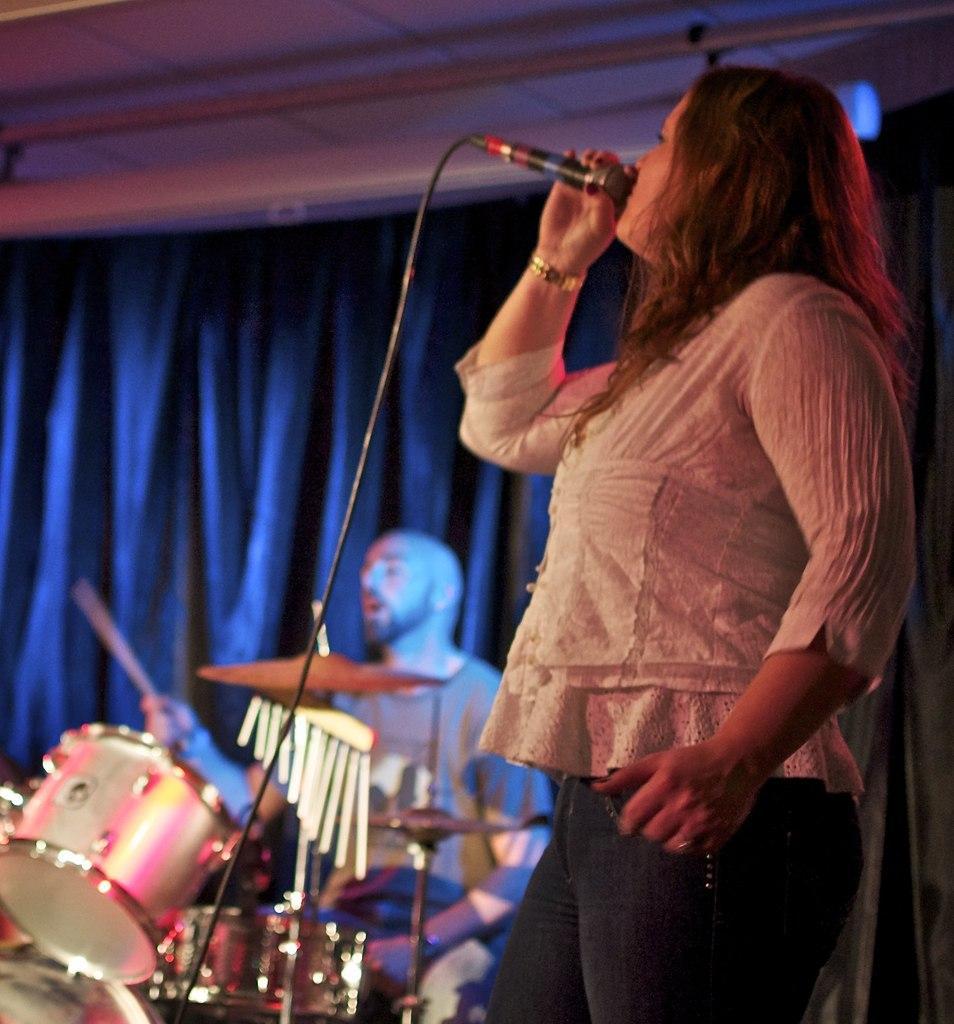Can you describe this image briefly? In this image there a person holding a microphone and a person playing a musical instrument, there is a curtain and a pole attached to the roof. 